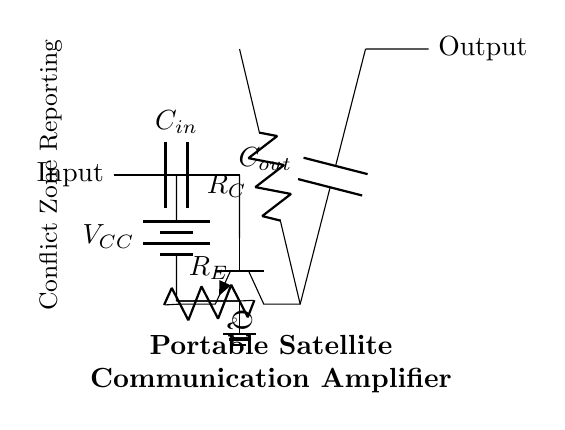What type of transistor is used? The circuit uses an NPN transistor, as indicated by the label "npn" next to Q1 in the diagram.
Answer: NPN What do the letters R and C represent in the circuit? R and C represent resistors and capacitors respectively; R is for biasing and C for coupling in the amplifier.
Answer: Resistors and capacitors What is the function of the input capacitor? The input capacitor (C_in) is used to block DC voltage while allowing AC signals to pass through, crucial for amplifying communication signals.
Answer: Block DC, allow AC What is the purpose of the output capacitor? The output capacitor (C_out) serves to block DC voltage while allowing the amplified AC signals to pass to the output, ensuring the signal integrity.
Answer: Block DC, allow AC How many resistors are present in the circuit? There are two resistors in the circuit, R_E (emitter resistor) and R_C (collector resistor), as depicted in the diagram.
Answer: Two What is the role of the V_CC in the circuit? V_CC acts as the power supply for the transistor, providing the necessary voltage for operation and amplification of signals.
Answer: Power supply Which component connects to ground? The ground is connected to the emitter side of the NPN transistor through R_E, ensuring a reference point for the circuit's operation.
Answer: Emitter (R_E) 